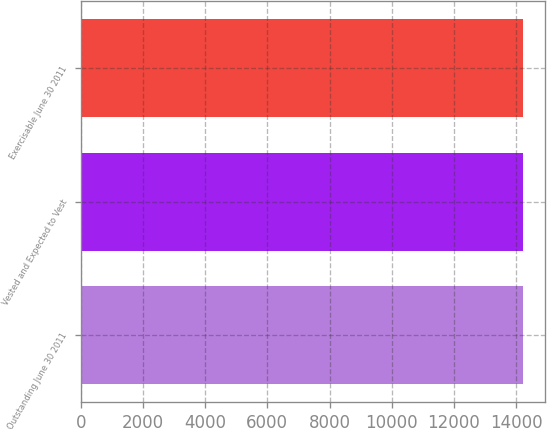Convert chart. <chart><loc_0><loc_0><loc_500><loc_500><bar_chart><fcel>Outstanding June 30 2011<fcel>Vested and Expected to Vest<fcel>Exercisable June 30 2011<nl><fcel>14216<fcel>14216.1<fcel>14216.2<nl></chart> 